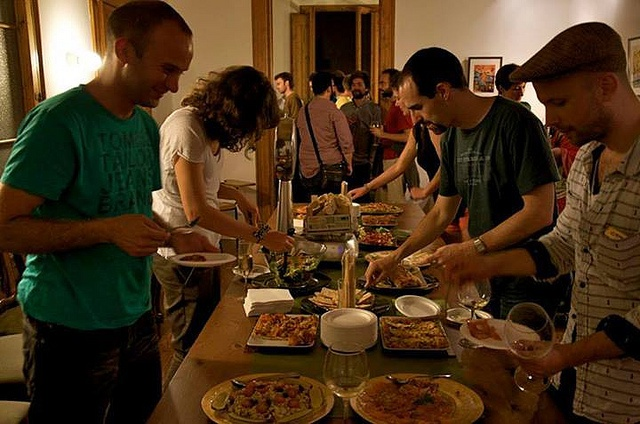Describe the objects in this image and their specific colors. I can see dining table in black, maroon, and brown tones, people in black, maroon, and darkgreen tones, people in black, maroon, and gray tones, people in black, maroon, and brown tones, and people in black, maroon, and gray tones in this image. 